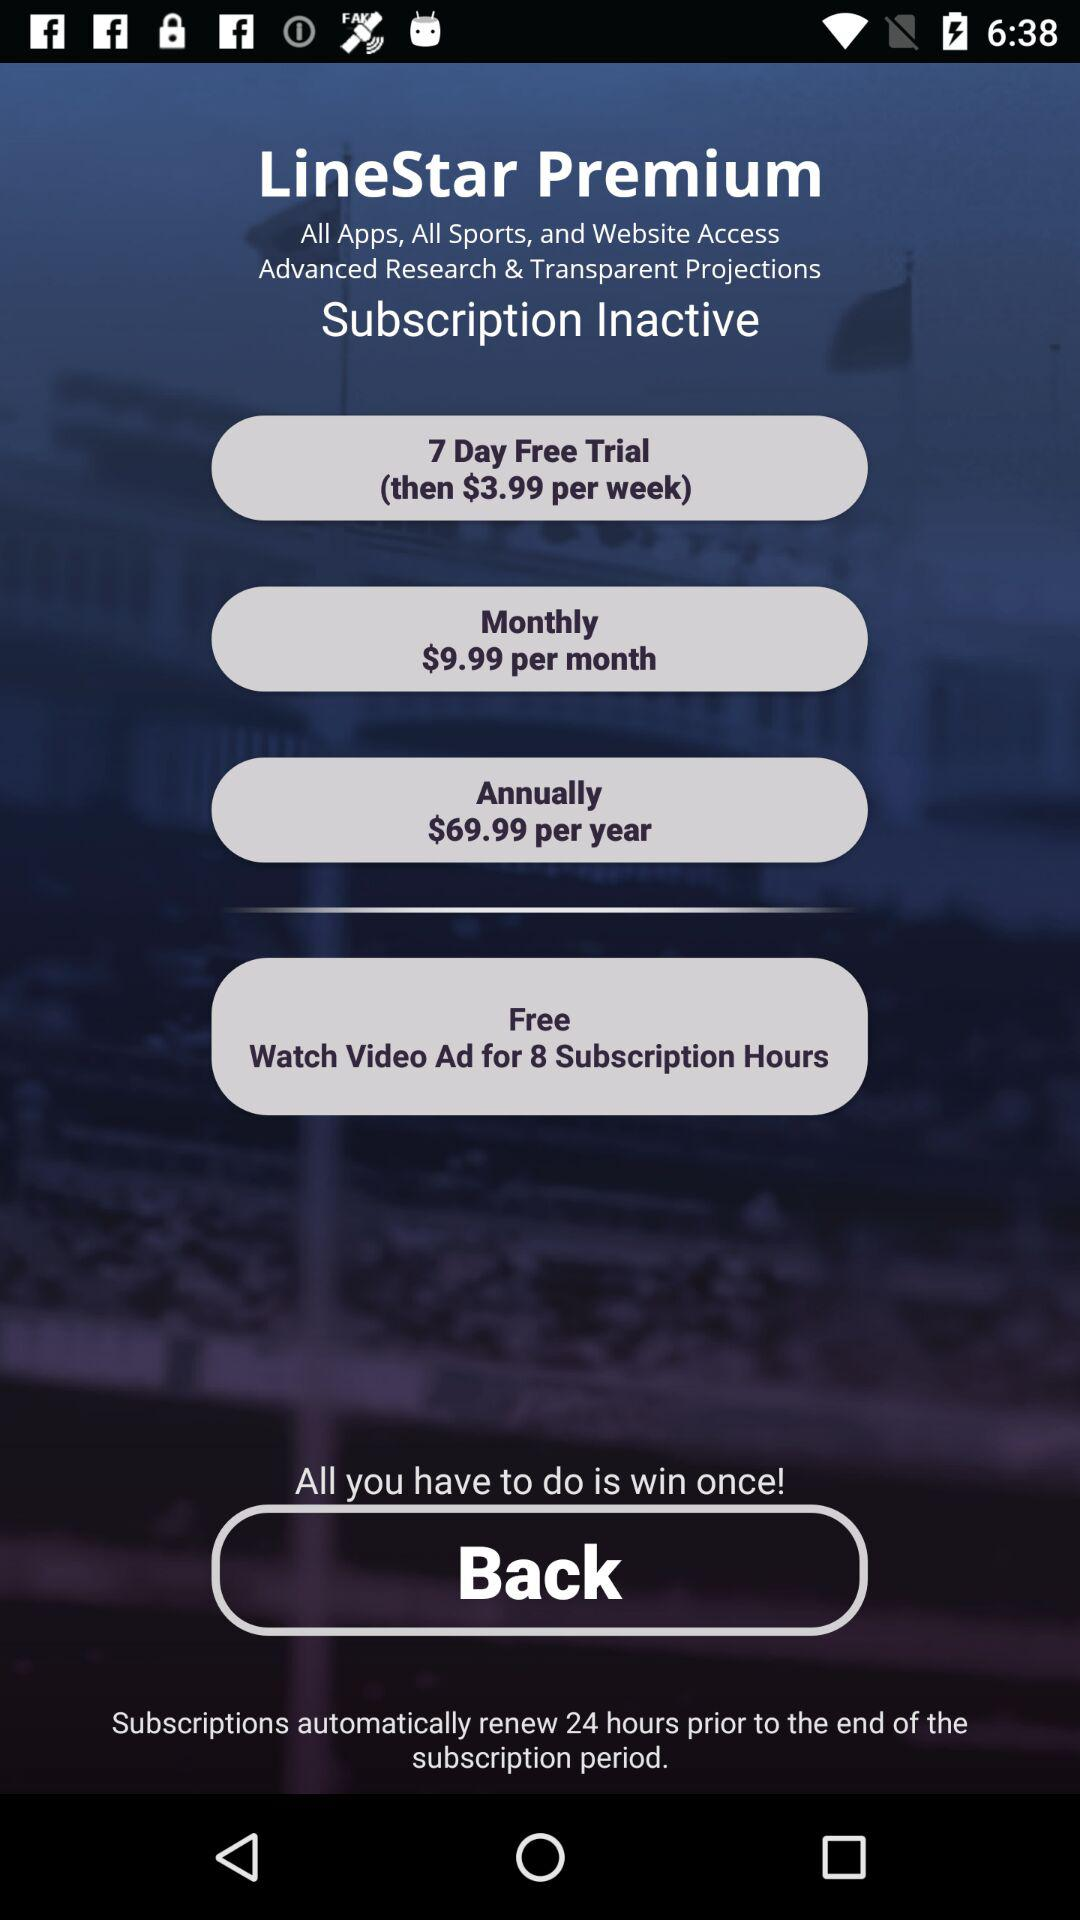What are the annual charges? The annual charges are $69.99. 